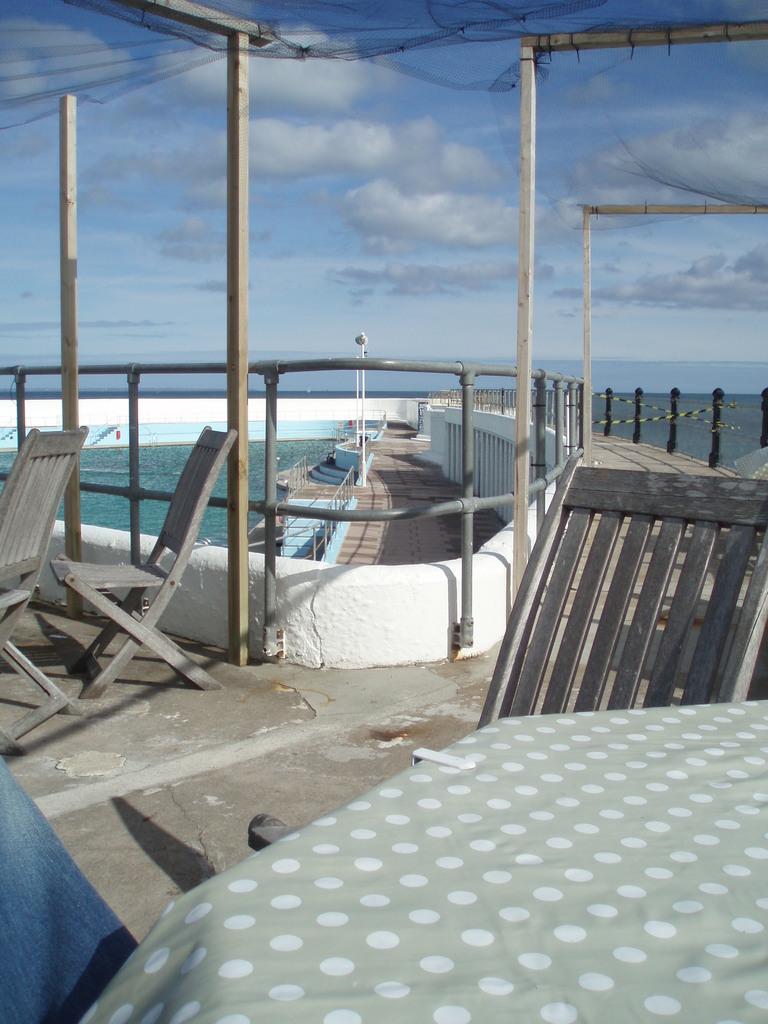How would you summarize this image in a sentence or two? In this image we can see a wall with fencing. Behind the wall we can see the water. In front of the wall we can see the wooden objects and the chairs. On the left side, we can see the barrier. At the bottom we can see a cloth. At the top we can see the sky. 